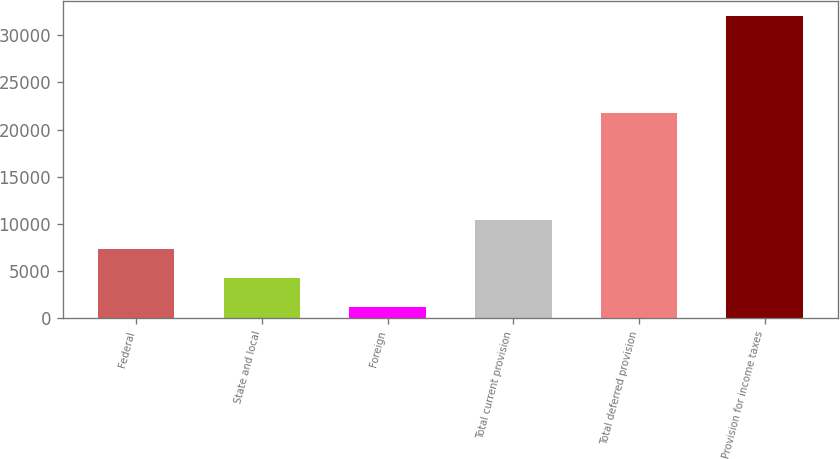<chart> <loc_0><loc_0><loc_500><loc_500><bar_chart><fcel>Federal<fcel>State and local<fcel>Foreign<fcel>Total current provision<fcel>Total deferred provision<fcel>Provision for income taxes<nl><fcel>7355.8<fcel>4274.9<fcel>1194<fcel>10436.7<fcel>21773<fcel>32003<nl></chart> 